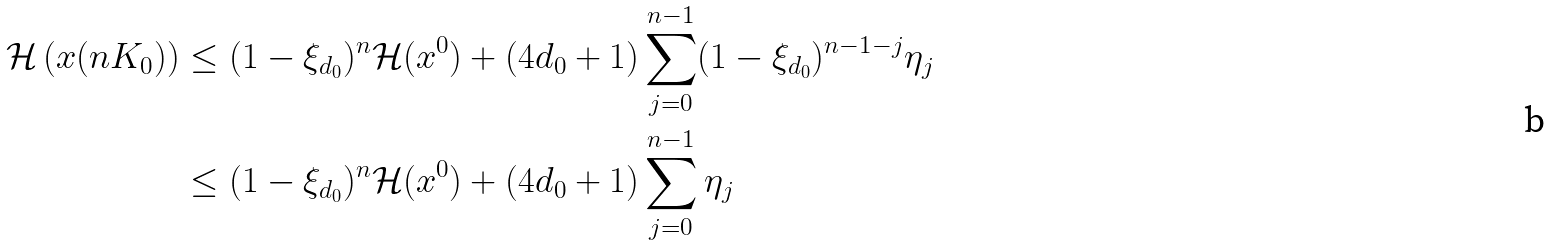Convert formula to latex. <formula><loc_0><loc_0><loc_500><loc_500>\mathcal { H } \left ( x ( n K _ { 0 } ) \right ) & \leq ( 1 - \xi _ { d _ { 0 } } ) ^ { n } \mathcal { H } ( x ^ { 0 } ) + ( 4 d _ { 0 } + 1 ) \sum _ { j = 0 } ^ { n - 1 } ( 1 - \xi _ { d _ { 0 } } ) ^ { n - 1 - j } \eta _ { j } \\ & \leq ( 1 - \xi _ { d _ { 0 } } ) ^ { n } \mathcal { H } ( x ^ { 0 } ) + ( 4 d _ { 0 } + 1 ) \sum _ { j = 0 } ^ { n - 1 } \eta _ { j }</formula> 